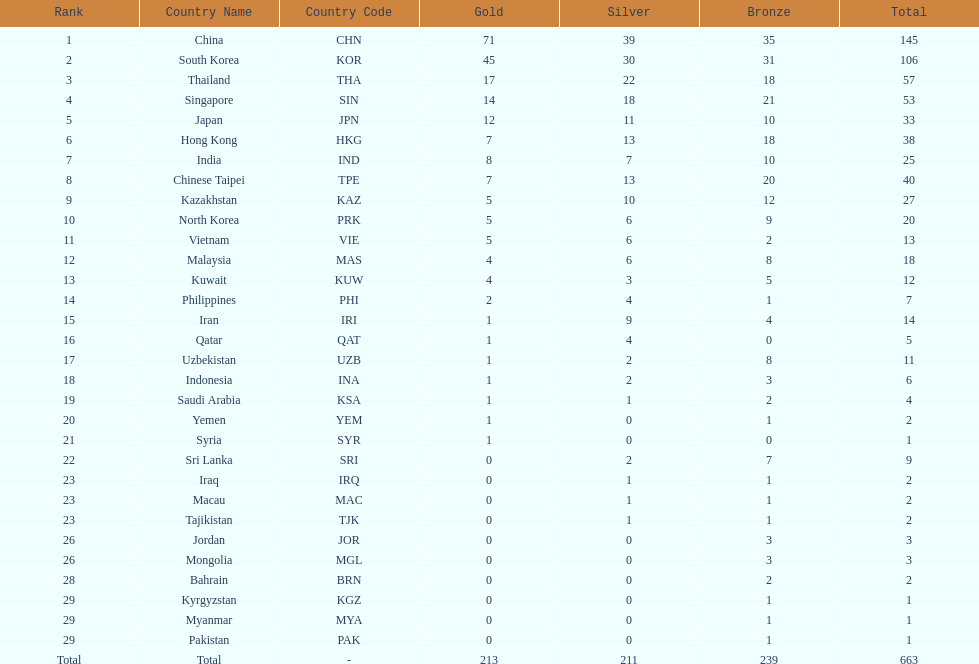How many countries have at least 10 gold medals in the asian youth games? 5. 